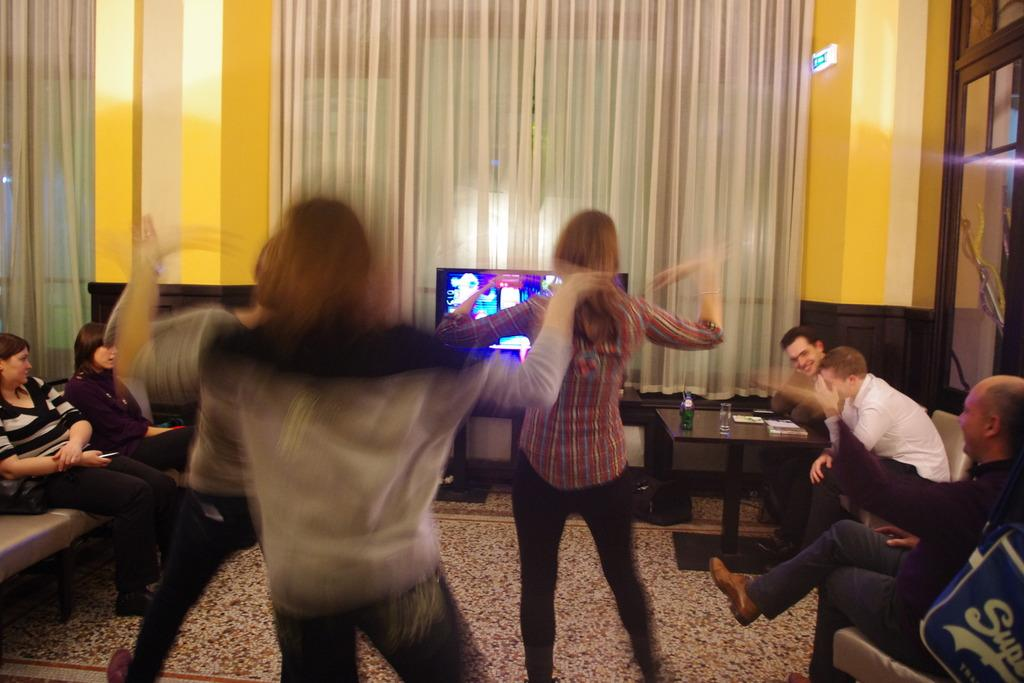What are the people in the image doing while sitting on the couch? There is no specific activity mentioned for the people sitting on the couch, but they are likely engaged in conversation or watching the television. What are the people doing who are not sitting on the couch? The people who are not sitting on the couch are dancing in the image. What is in front of the people in the image? There is a television in front of the people in the image. What type of window treatment is present in the image? There is a curtain in the image. What architectural feature is visible in the image? There are doors visible in the image. What type of chalk is being used by the people dancing in the image? There is no chalk present in the image; the people are dancing without any chalk. How does the power of the television affect the people sitting on the couch? The power of the television does not affect the people sitting on the couch in the image, as it is not mentioned or implied in the provided facts. 